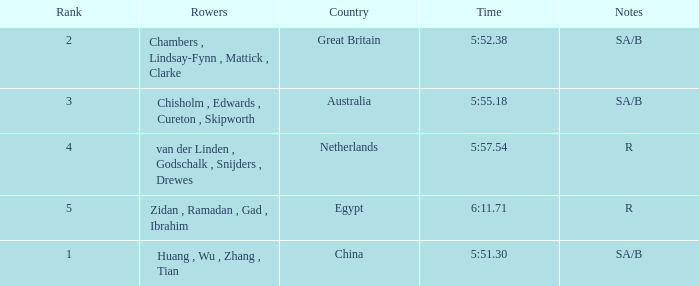What country has sa/b as the notes, and a time of 5:51.30? China. 